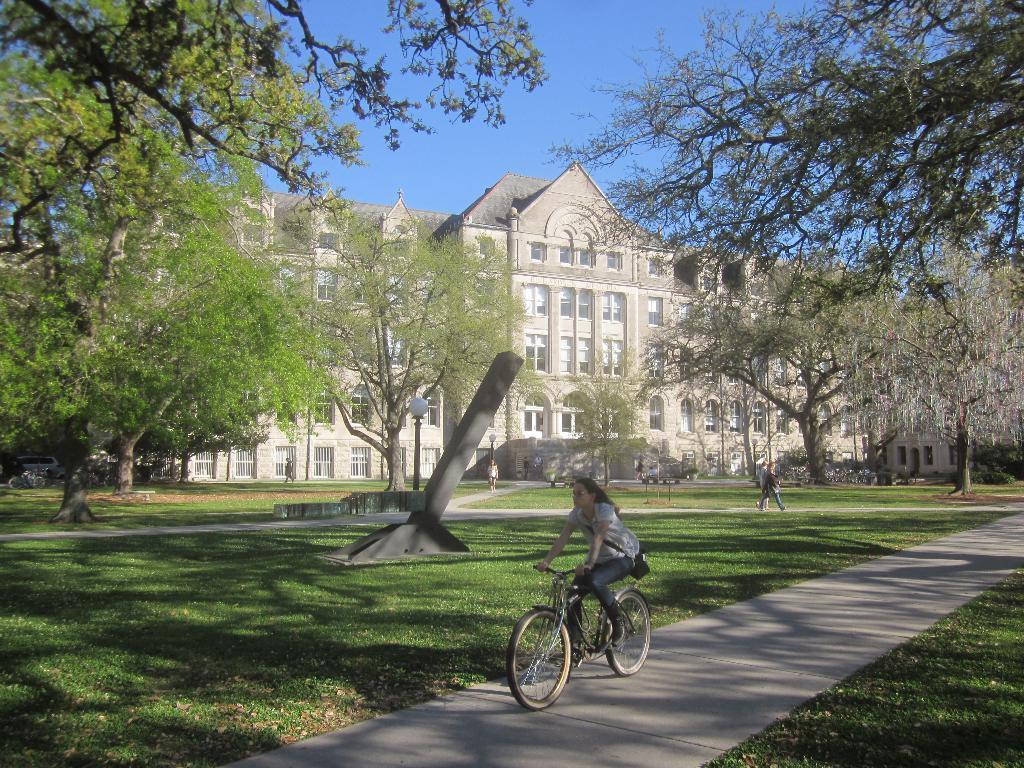Can you describe this image briefly? In this picture I can see there is a woman riding a bicycle and there are two more persons walking in the backdrop and there's grass on to right and left side and there are trees, buildings and it has doors, buildings and the sky is clear. 